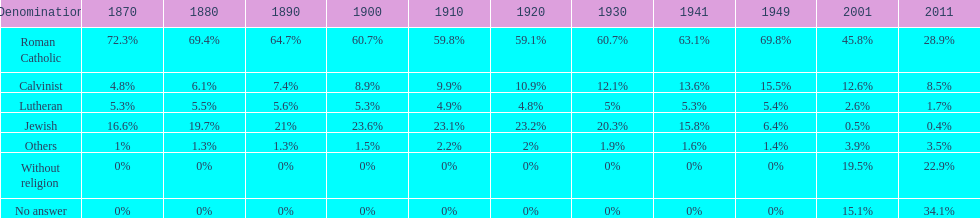What proportion of the population identified themselves as religious in the year 2011? 43%. Could you parse the entire table? {'header': ['Denomination', '1870', '1880', '1890', '1900', '1910', '1920', '1930', '1941', '1949', '2001', '2011'], 'rows': [['Roman Catholic', '72.3%', '69.4%', '64.7%', '60.7%', '59.8%', '59.1%', '60.7%', '63.1%', '69.8%', '45.8%', '28.9%'], ['Calvinist', '4.8%', '6.1%', '7.4%', '8.9%', '9.9%', '10.9%', '12.1%', '13.6%', '15.5%', '12.6%', '8.5%'], ['Lutheran', '5.3%', '5.5%', '5.6%', '5.3%', '4.9%', '4.8%', '5%', '5.3%', '5.4%', '2.6%', '1.7%'], ['Jewish', '16.6%', '19.7%', '21%', '23.6%', '23.1%', '23.2%', '20.3%', '15.8%', '6.4%', '0.5%', '0.4%'], ['Others', '1%', '1.3%', '1.3%', '1.5%', '2.2%', '2%', '1.9%', '1.6%', '1.4%', '3.9%', '3.5%'], ['Without religion', '0%', '0%', '0%', '0%', '0%', '0%', '0%', '0%', '0%', '19.5%', '22.9%'], ['No answer', '0%', '0%', '0%', '0%', '0%', '0%', '0%', '0%', '0%', '15.1%', '34.1%']]} 